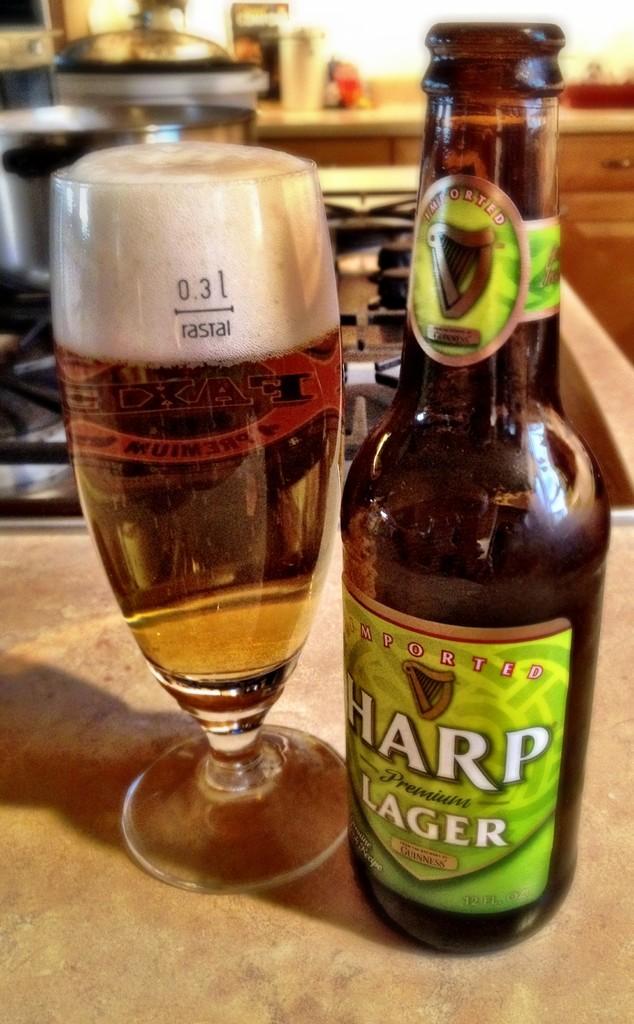How many ounces are in this beer?
Your answer should be compact. 12. 